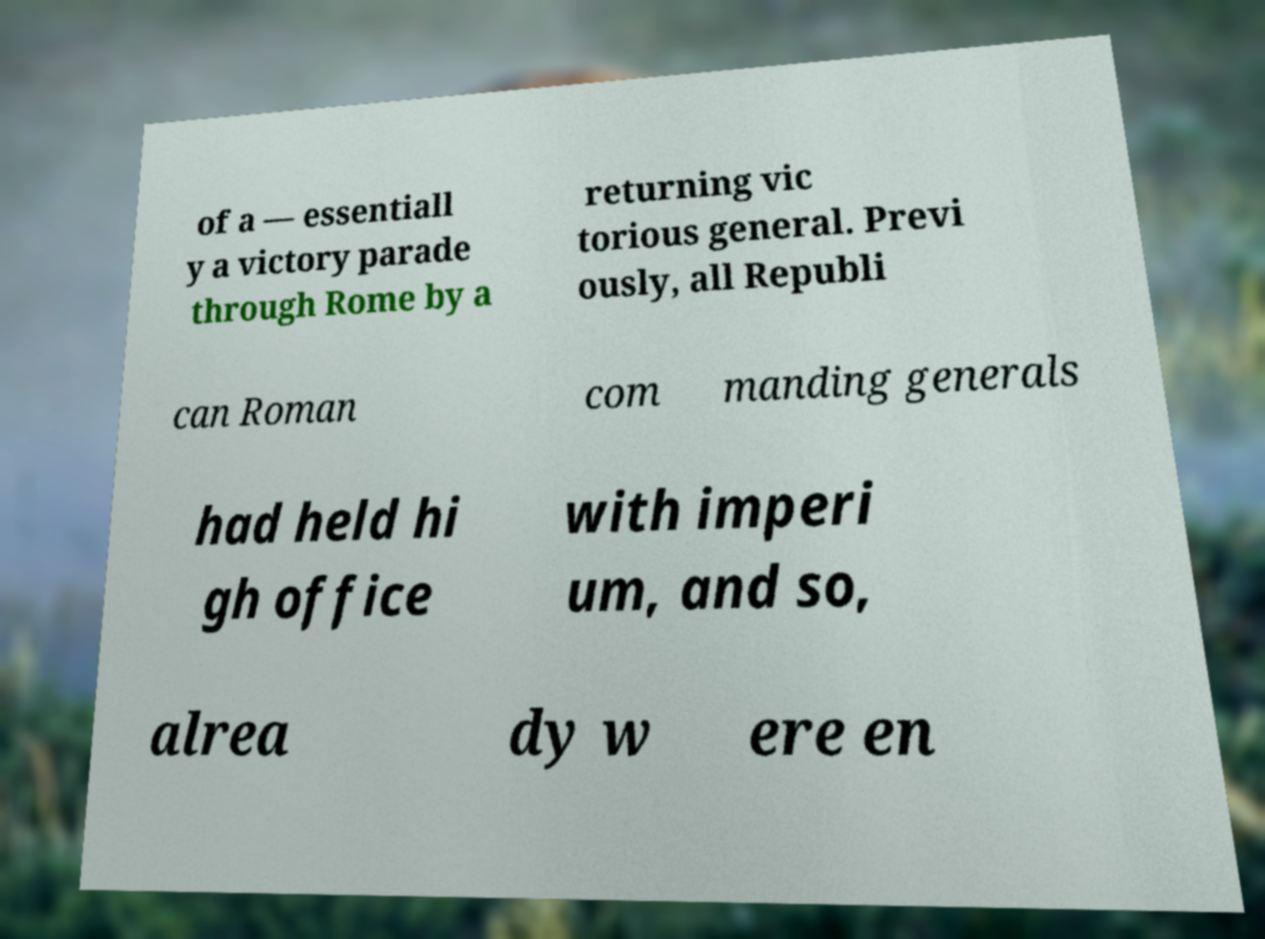Please read and relay the text visible in this image. What does it say? of a — essentiall y a victory parade through Rome by a returning vic torious general. Previ ously, all Republi can Roman com manding generals had held hi gh office with imperi um, and so, alrea dy w ere en 